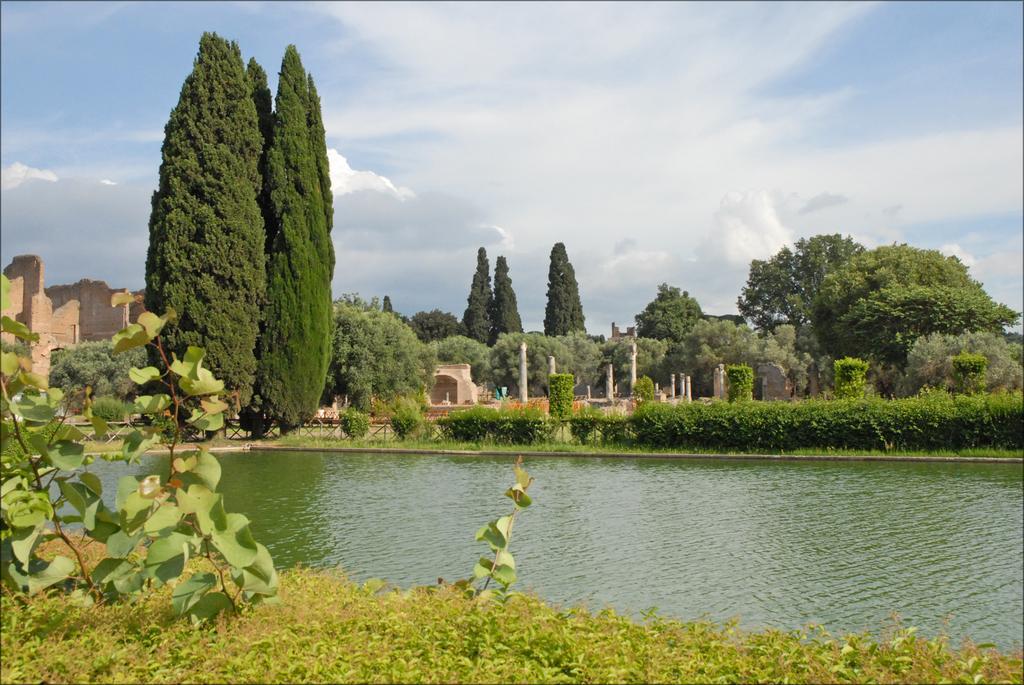Describe this image in one or two sentences. In the image there is a water surface and around the water surface there is a beautiful park with many trees and plants, in the background there is a fort. 